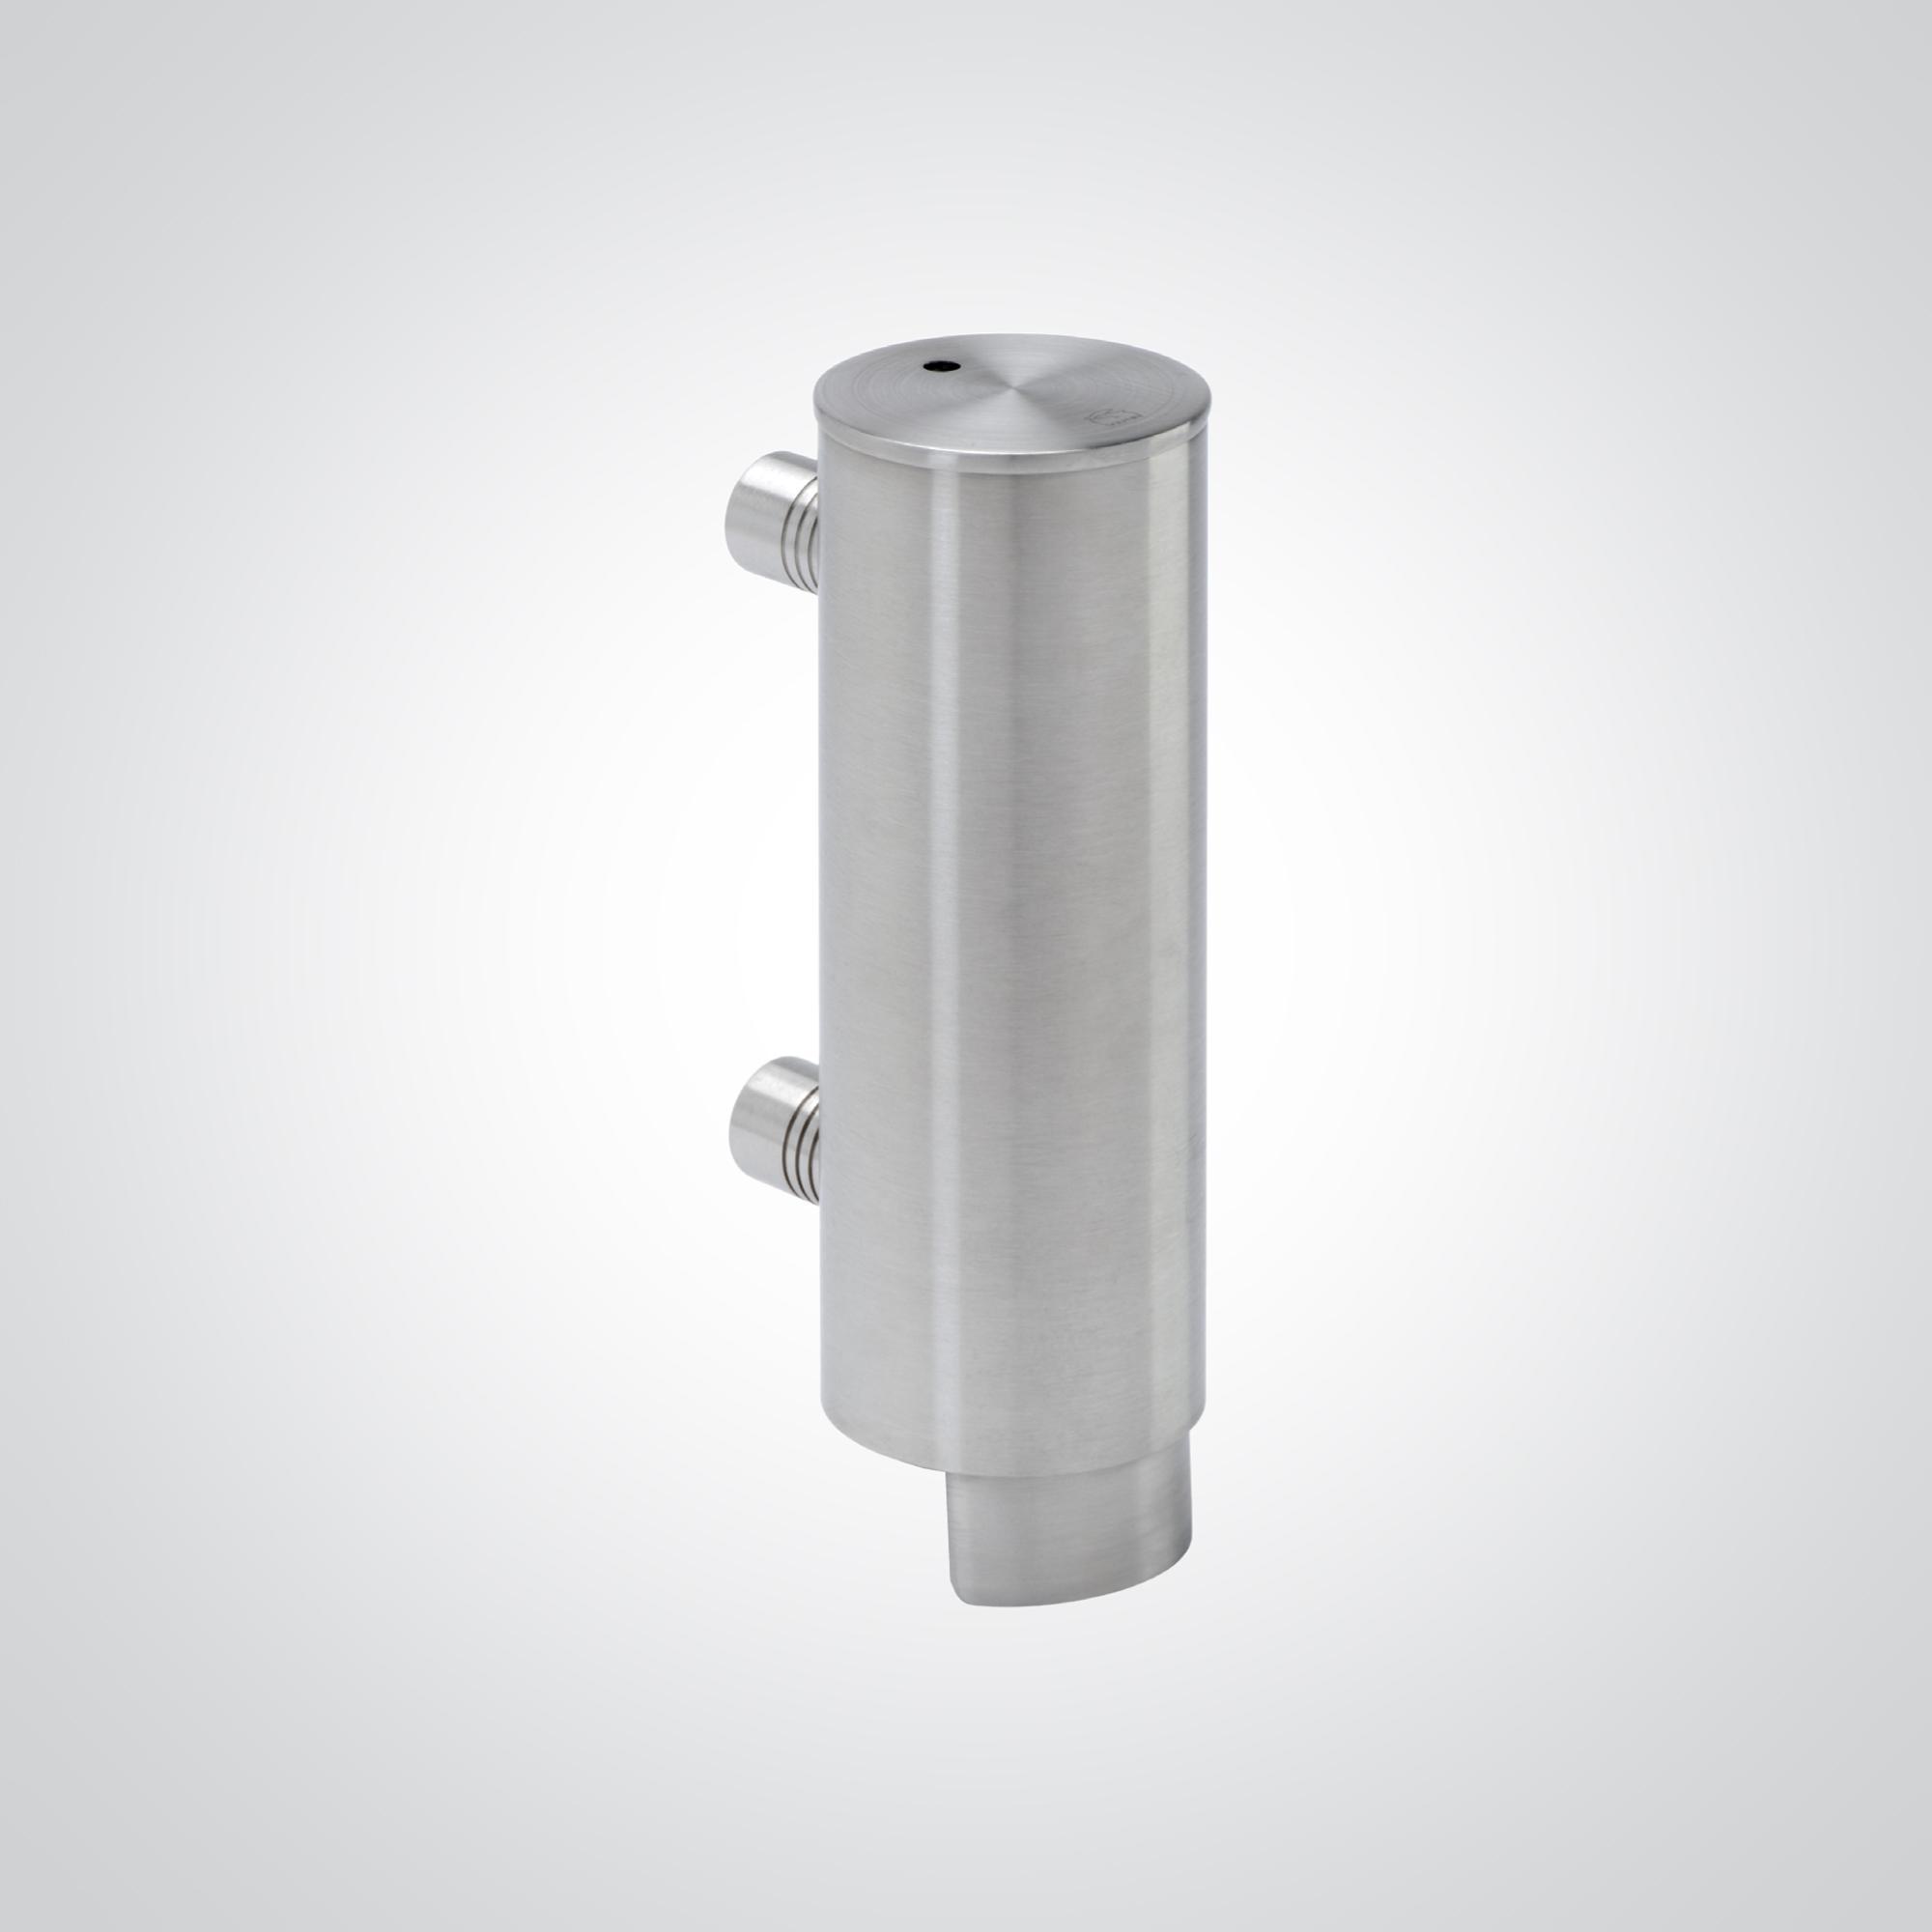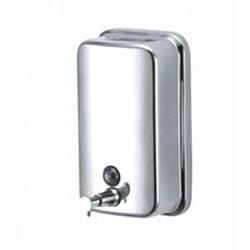The first image is the image on the left, the second image is the image on the right. Considering the images on both sides, is "The dispenser on the right is a cylinder with a narrow nozzle." valid? Answer yes or no. No. The first image is the image on the left, the second image is the image on the right. Given the left and right images, does the statement "The dispenser on the right image is tall and round." hold true? Answer yes or no. No. 